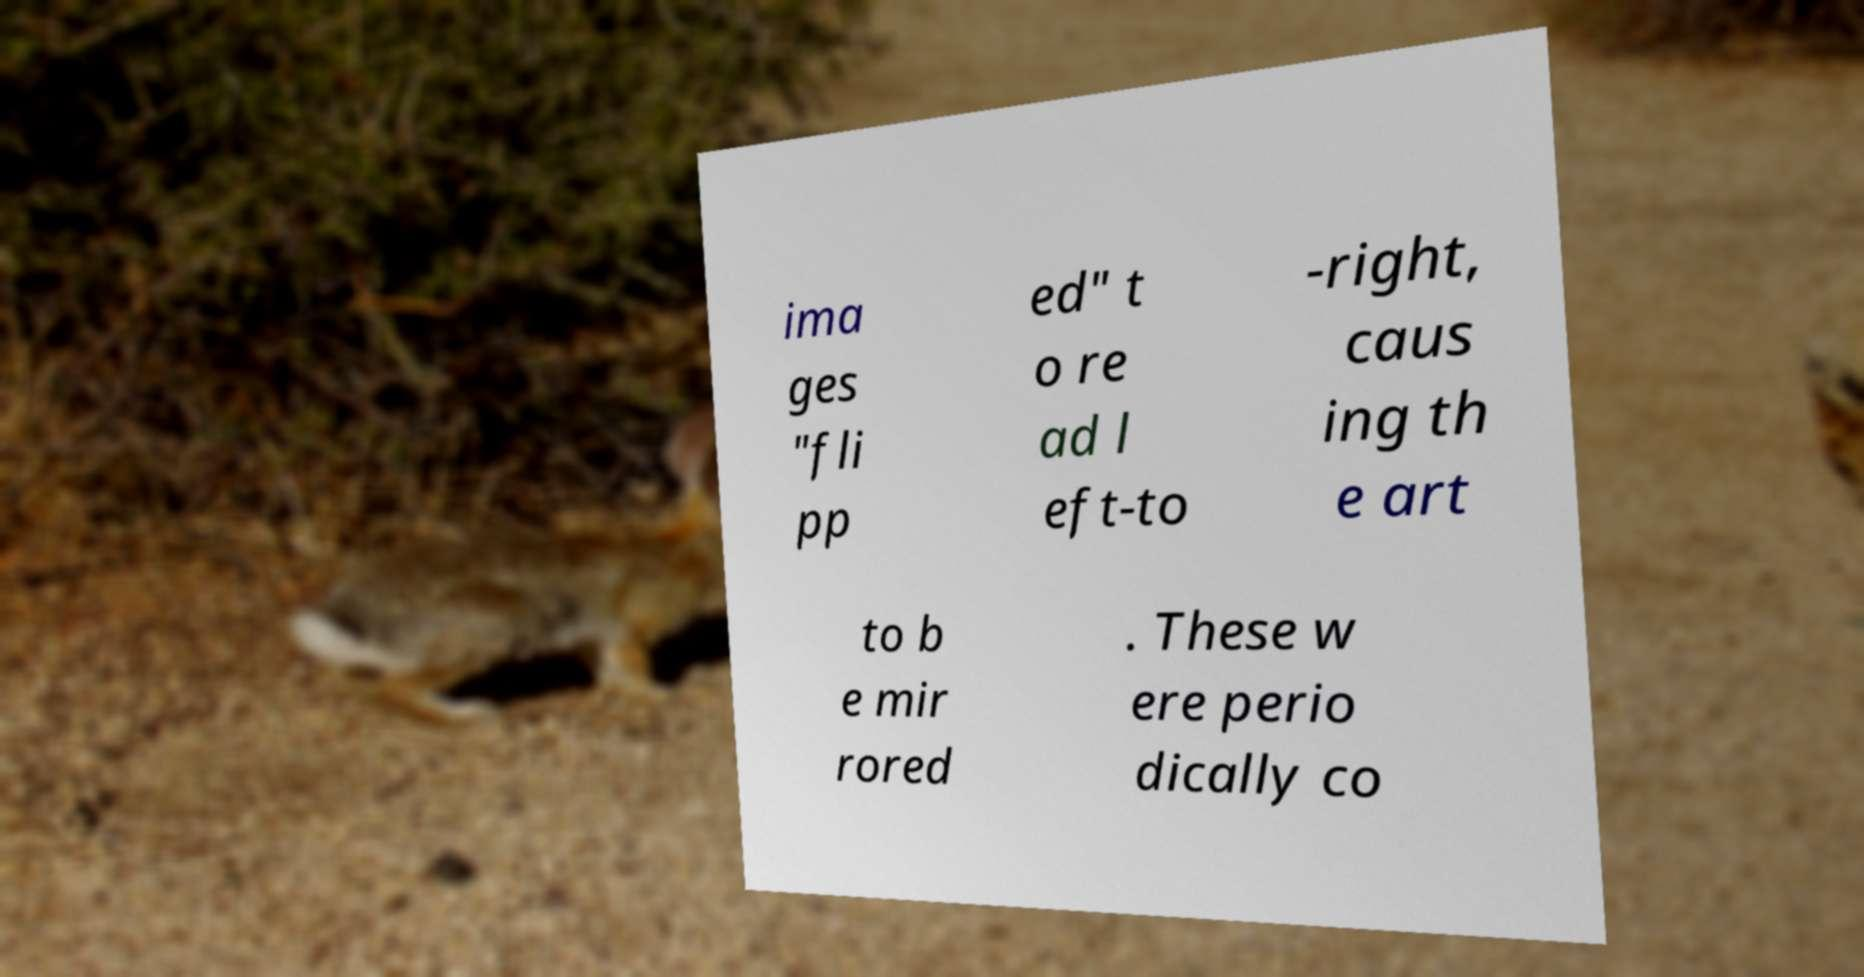Could you assist in decoding the text presented in this image and type it out clearly? ima ges "fli pp ed" t o re ad l eft-to -right, caus ing th e art to b e mir rored . These w ere perio dically co 